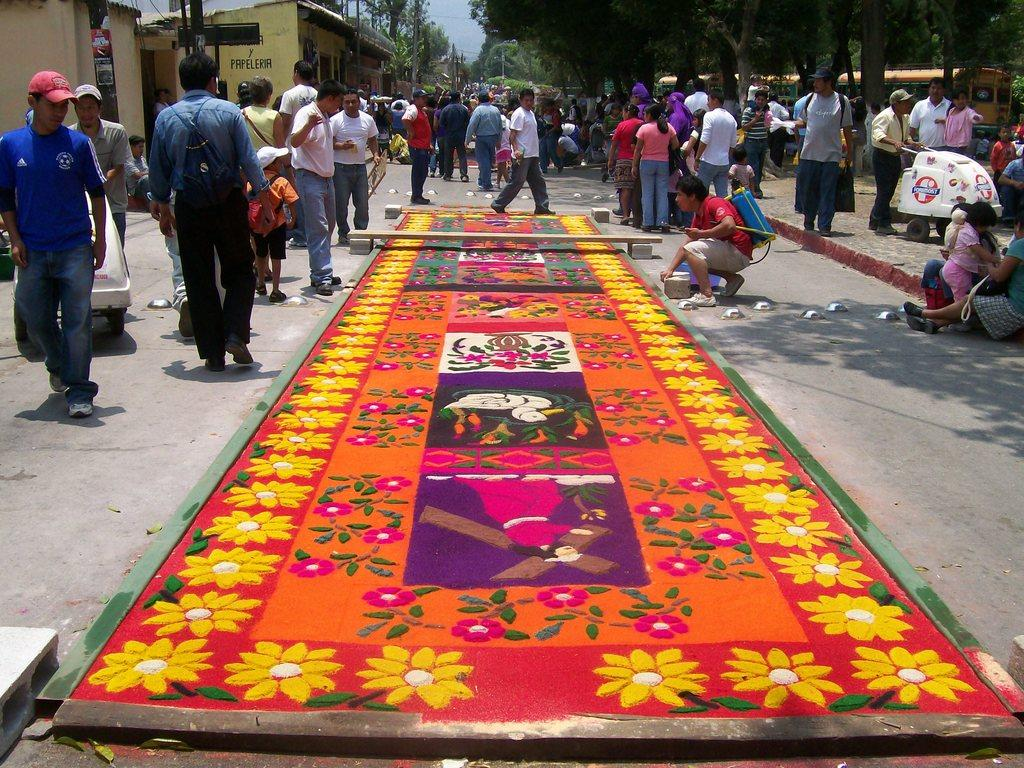What are the people in the image doing? There are people standing and walking in the image. What type of vegetation can be seen in the image? There are trees visible in the image. What mode of transportation is present on the right side of the image? There is a bus on the right side of the image. What type of structures can be seen in the image? There are homes in the image. What theory is being discussed by the achiever in the image? There is no achiever present in the image, and therefore no theory is being discussed. Is the image set during winter, as indicated by the presence of snow? There is no snow present in the image, and no information is given about the season or weather conditions. 